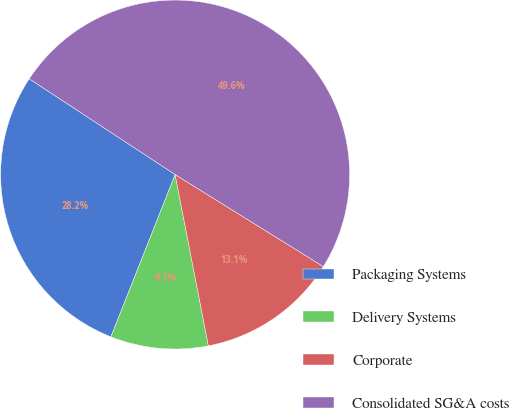Convert chart to OTSL. <chart><loc_0><loc_0><loc_500><loc_500><pie_chart><fcel>Packaging Systems<fcel>Delivery Systems<fcel>Corporate<fcel>Consolidated SG&A costs<nl><fcel>28.25%<fcel>9.05%<fcel>13.1%<fcel>49.6%<nl></chart> 